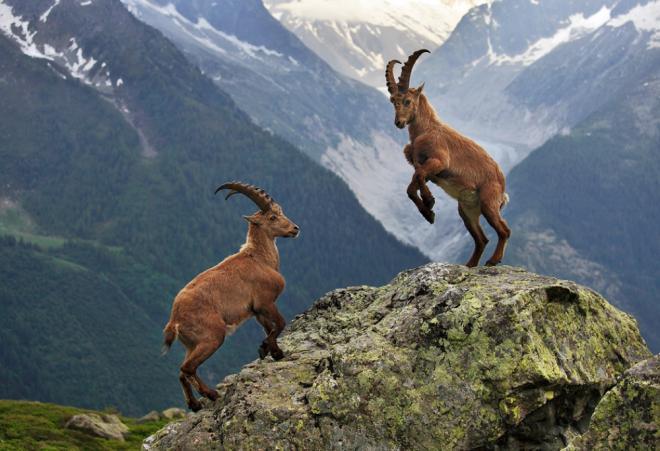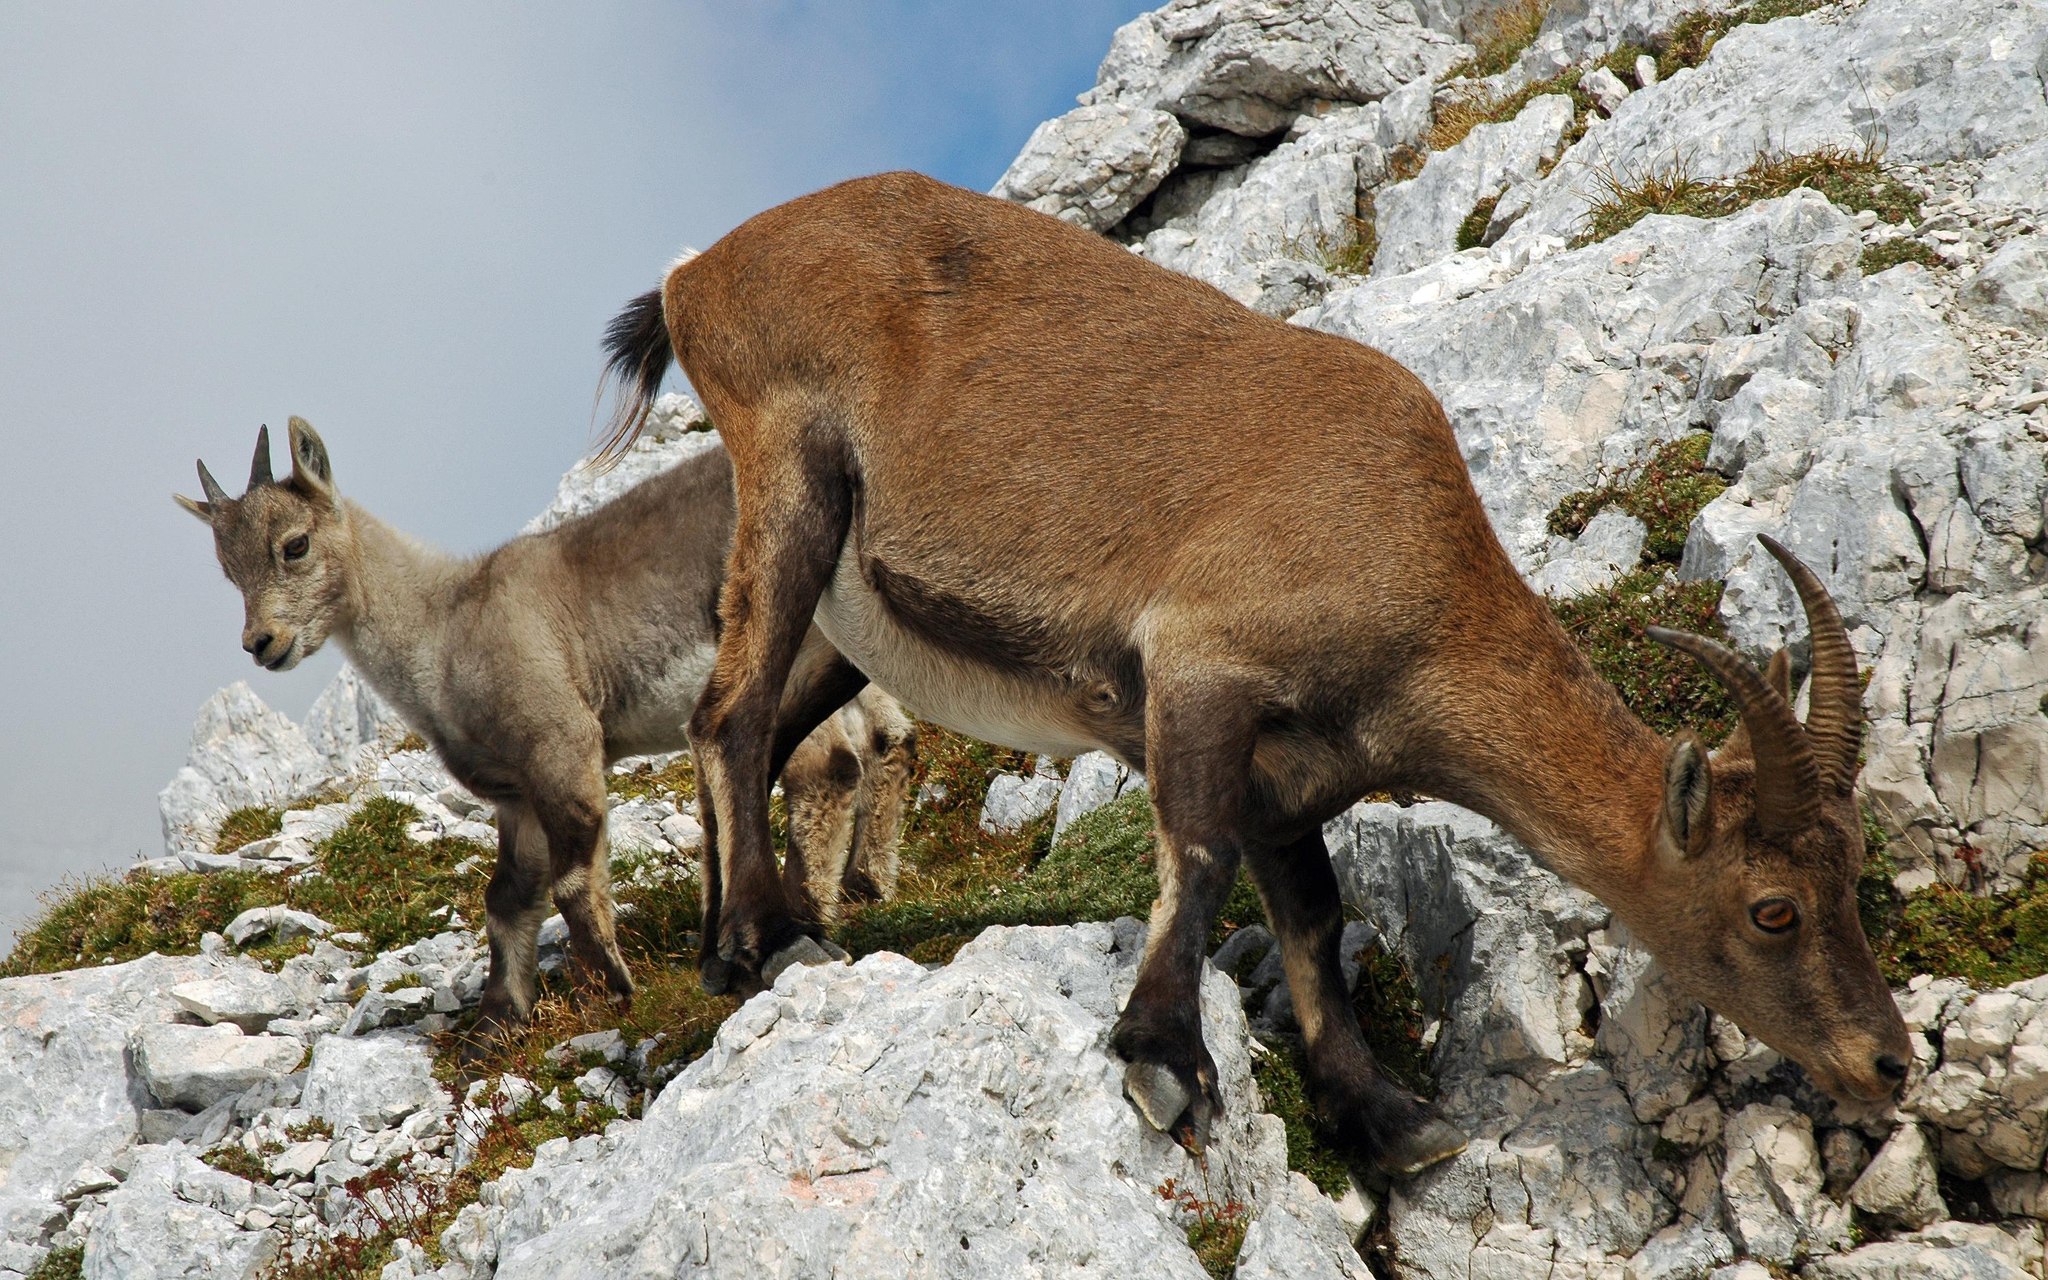The first image is the image on the left, the second image is the image on the right. For the images shown, is this caption "There are more rams in the image on the left." true? Answer yes or no. No. The first image is the image on the left, the second image is the image on the right. Examine the images to the left and right. Is the description "The right image contains exactly one mountain goat on a rocky cliff." accurate? Answer yes or no. No. The first image is the image on the left, the second image is the image on the right. Considering the images on both sides, is "The left image contains exactly two mountain goats." valid? Answer yes or no. Yes. The first image is the image on the left, the second image is the image on the right. For the images displayed, is the sentence "A mountain goat stands on its hinds legs in front of a similarly colored horned animal." factually correct? Answer yes or no. Yes. 